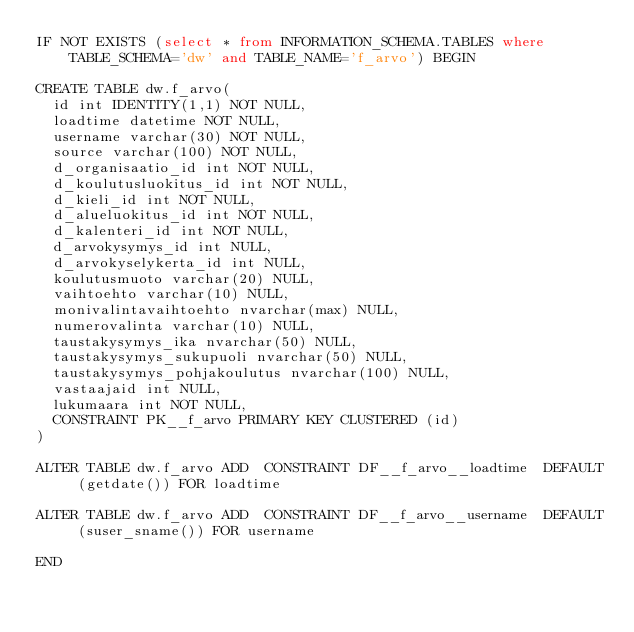<code> <loc_0><loc_0><loc_500><loc_500><_SQL_>IF NOT EXISTS (select * from INFORMATION_SCHEMA.TABLES where TABLE_SCHEMA='dw' and TABLE_NAME='f_arvo') BEGIN

CREATE TABLE dw.f_arvo(
  id int IDENTITY(1,1) NOT NULL,
  loadtime datetime NOT NULL,
  username varchar(30) NOT NULL,
  source varchar(100) NOT NULL,
  d_organisaatio_id int NOT NULL,
  d_koulutusluokitus_id int NOT NULL,
  d_kieli_id int NOT NULL,
  d_alueluokitus_id int NOT NULL,
  d_kalenteri_id int NOT NULL,
  d_arvokysymys_id int NULL,
  d_arvokyselykerta_id int NULL,
  koulutusmuoto varchar(20) NULL,
  vaihtoehto varchar(10) NULL,
  monivalintavaihtoehto nvarchar(max) NULL,
  numerovalinta varchar(10) NULL,
  taustakysymys_ika nvarchar(50) NULL,
  taustakysymys_sukupuoli nvarchar(50) NULL,
  taustakysymys_pohjakoulutus nvarchar(100) NULL,
  vastaajaid int NULL,
  lukumaara int NOT NULL,
  CONSTRAINT PK__f_arvo PRIMARY KEY CLUSTERED (id)
)

ALTER TABLE dw.f_arvo ADD  CONSTRAINT DF__f_arvo__loadtime  DEFAULT (getdate()) FOR loadtime

ALTER TABLE dw.f_arvo ADD  CONSTRAINT DF__f_arvo__username  DEFAULT (suser_sname()) FOR username

END
</code> 